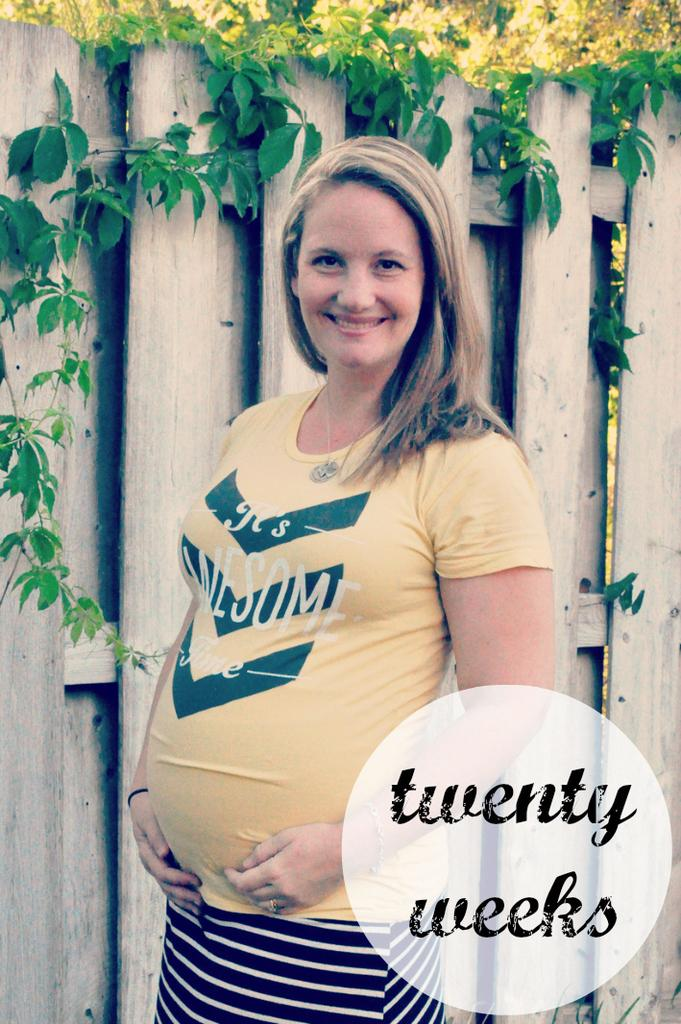<image>
Share a concise interpretation of the image provided. A woman wearing a yellow t-shirt is smiling and is twenty weeks pregnant. 